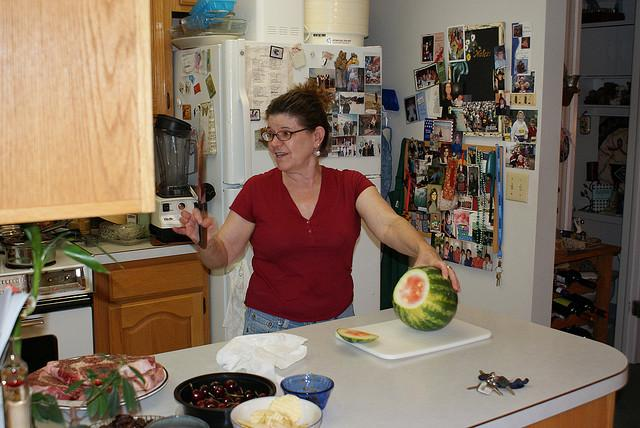What is the appliance next to the refrigerator? blender 